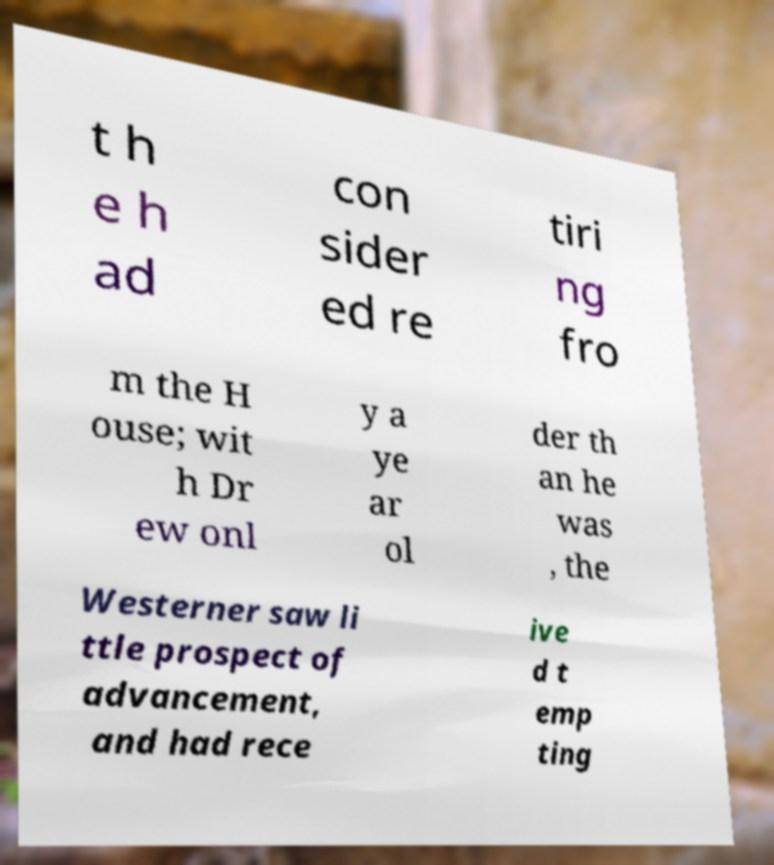Could you assist in decoding the text presented in this image and type it out clearly? t h e h ad con sider ed re tiri ng fro m the H ouse; wit h Dr ew onl y a ye ar ol der th an he was , the Westerner saw li ttle prospect of advancement, and had rece ive d t emp ting 